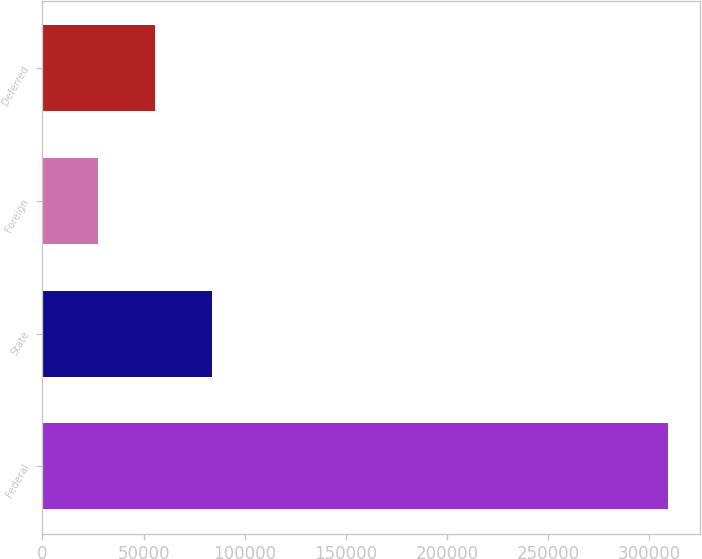Convert chart. <chart><loc_0><loc_0><loc_500><loc_500><bar_chart><fcel>Federal<fcel>State<fcel>Foreign<fcel>Deferred<nl><fcel>309403<fcel>83962.2<fcel>27602<fcel>55782.1<nl></chart> 